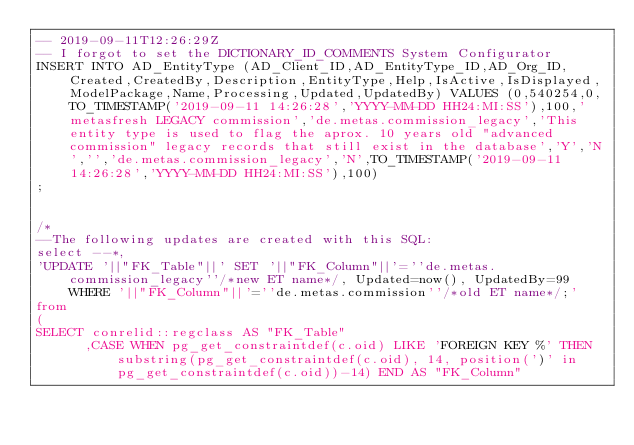<code> <loc_0><loc_0><loc_500><loc_500><_SQL_>-- 2019-09-11T12:26:29Z
-- I forgot to set the DICTIONARY_ID_COMMENTS System Configurator
INSERT INTO AD_EntityType (AD_Client_ID,AD_EntityType_ID,AD_Org_ID,Created,CreatedBy,Description,EntityType,Help,IsActive,IsDisplayed,ModelPackage,Name,Processing,Updated,UpdatedBy) VALUES (0,540254,0,TO_TIMESTAMP('2019-09-11 14:26:28','YYYY-MM-DD HH24:MI:SS'),100,'metasfresh LEGACY commission','de.metas.commission_legacy','This entity type is used to flag the aprox. 10 years old "advanced commission" legacy records that still exist in the database','Y','N','','de.metas.commission_legacy','N',TO_TIMESTAMP('2019-09-11 14:26:28','YYYY-MM-DD HH24:MI:SS'),100)
;


/*
--The following updates are created with this SQL:
select --*, 
'UPDATE '||"FK_Table"||' SET '||"FK_Column"||'=''de.metas.commission_legacy''/*new ET name*/, Updated=now(), UpdatedBy=99 WHERE '||"FK_Column"||'=''de.metas.commission''/*old ET name*/;'
from
(
SELECT conrelid::regclass AS "FK_Table"
      ,CASE WHEN pg_get_constraintdef(c.oid) LIKE 'FOREIGN KEY %' THEN substring(pg_get_constraintdef(c.oid), 14, position(')' in pg_get_constraintdef(c.oid))-14) END AS "FK_Column"</code> 